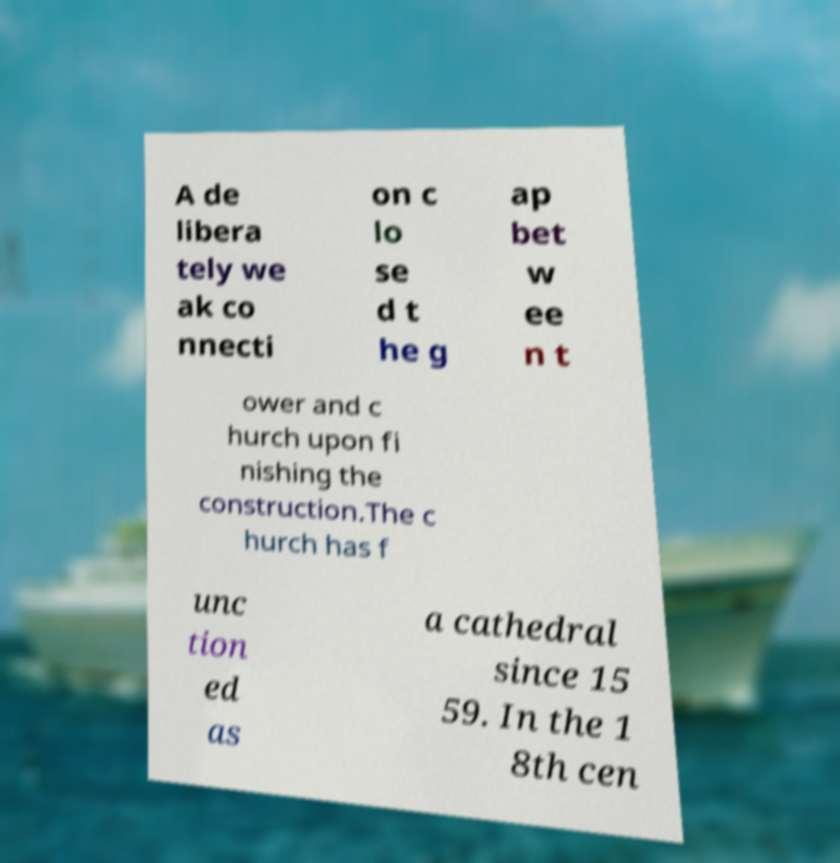For documentation purposes, I need the text within this image transcribed. Could you provide that? A de libera tely we ak co nnecti on c lo se d t he g ap bet w ee n t ower and c hurch upon fi nishing the construction.The c hurch has f unc tion ed as a cathedral since 15 59. In the 1 8th cen 